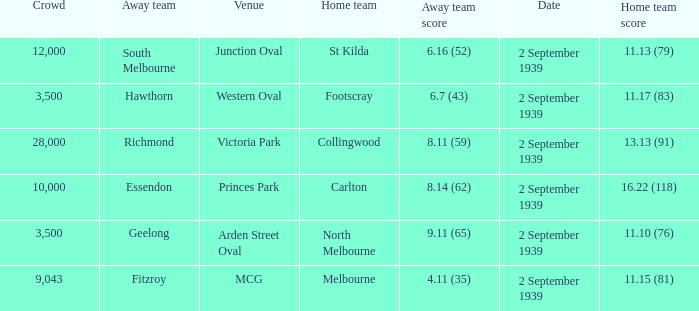Write the full table. {'header': ['Crowd', 'Away team', 'Venue', 'Home team', 'Away team score', 'Date', 'Home team score'], 'rows': [['12,000', 'South Melbourne', 'Junction Oval', 'St Kilda', '6.16 (52)', '2 September 1939', '11.13 (79)'], ['3,500', 'Hawthorn', 'Western Oval', 'Footscray', '6.7 (43)', '2 September 1939', '11.17 (83)'], ['28,000', 'Richmond', 'Victoria Park', 'Collingwood', '8.11 (59)', '2 September 1939', '13.13 (91)'], ['10,000', 'Essendon', 'Princes Park', 'Carlton', '8.14 (62)', '2 September 1939', '16.22 (118)'], ['3,500', 'Geelong', 'Arden Street Oval', 'North Melbourne', '9.11 (65)', '2 September 1939', '11.10 (76)'], ['9,043', 'Fitzroy', 'MCG', 'Melbourne', '4.11 (35)', '2 September 1939', '11.15 (81)']]} What was the crowd size of the match featuring Hawthorn as the Away team? 3500.0. 